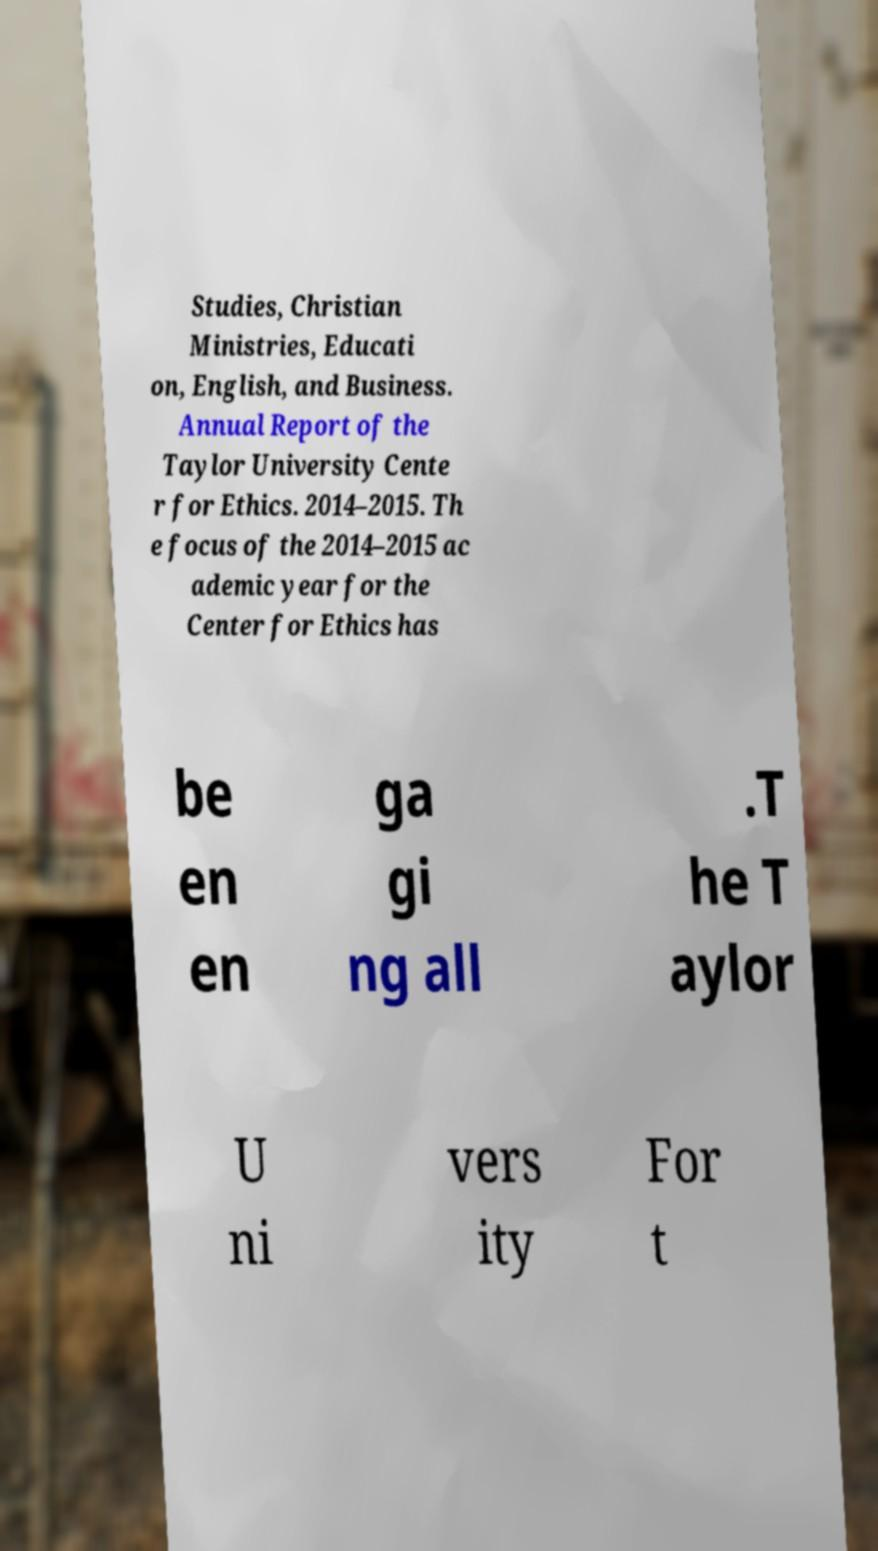Can you accurately transcribe the text from the provided image for me? Studies, Christian Ministries, Educati on, English, and Business. Annual Report of the Taylor University Cente r for Ethics. 2014–2015. Th e focus of the 2014–2015 ac ademic year for the Center for Ethics has be en en ga gi ng all .T he T aylor U ni vers ity For t 